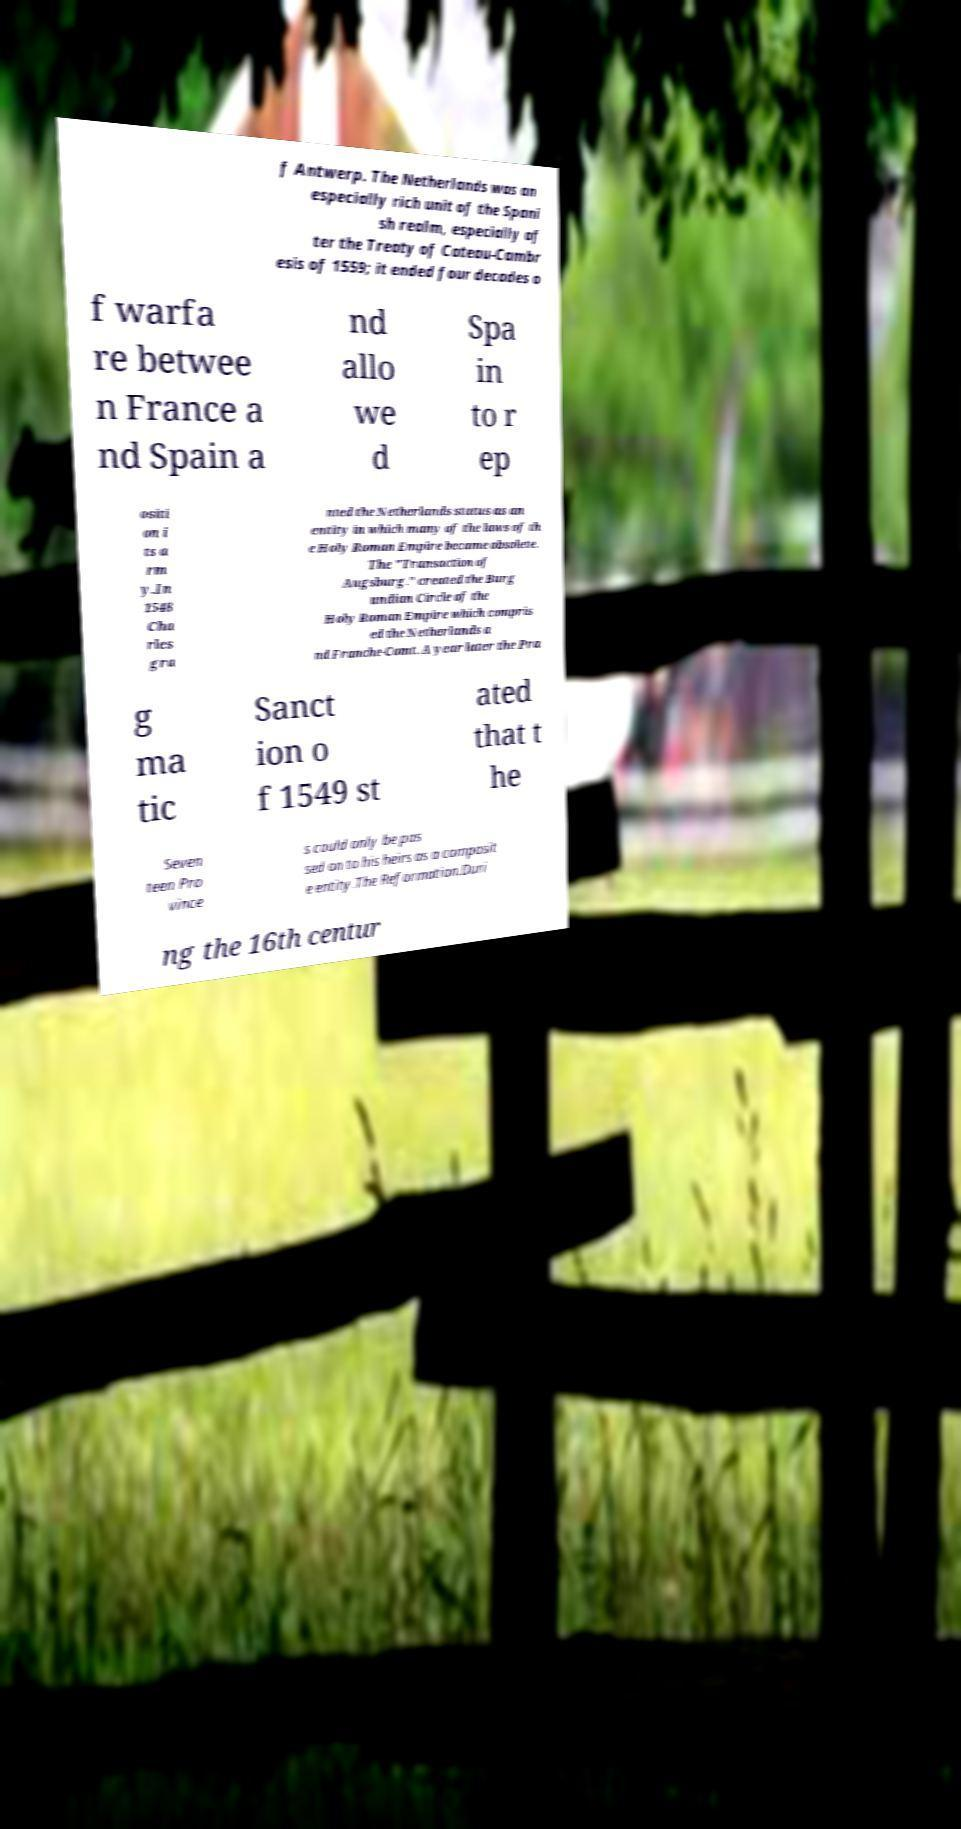Please read and relay the text visible in this image. What does it say? f Antwerp. The Netherlands was an especially rich unit of the Spani sh realm, especially af ter the Treaty of Cateau-Cambr esis of 1559; it ended four decades o f warfa re betwee n France a nd Spain a nd allo we d Spa in to r ep ositi on i ts a rm y.In 1548 Cha rles gra nted the Netherlands status as an entity in which many of the laws of th e Holy Roman Empire became obsolete. The "Transaction of Augsburg." created the Burg undian Circle of the Holy Roman Empire which compris ed the Netherlands a nd Franche-Comt. A year later the Pra g ma tic Sanct ion o f 1549 st ated that t he Seven teen Pro vince s could only be pas sed on to his heirs as a composit e entity.The Reformation.Duri ng the 16th centur 